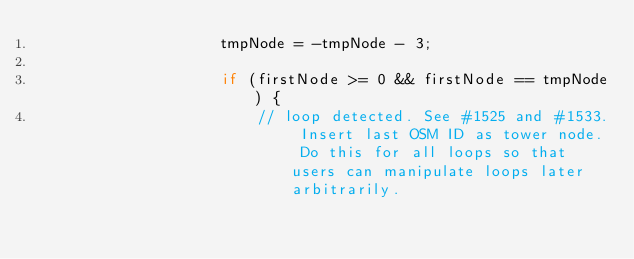Convert code to text. <code><loc_0><loc_0><loc_500><loc_500><_Java_>                    tmpNode = -tmpNode - 3;

                    if (firstNode >= 0 && firstNode == tmpNode) {
                        // loop detected. See #1525 and #1533. Insert last OSM ID as tower node. Do this for all loops so that users can manipulate loops later arbitrarily.</code> 